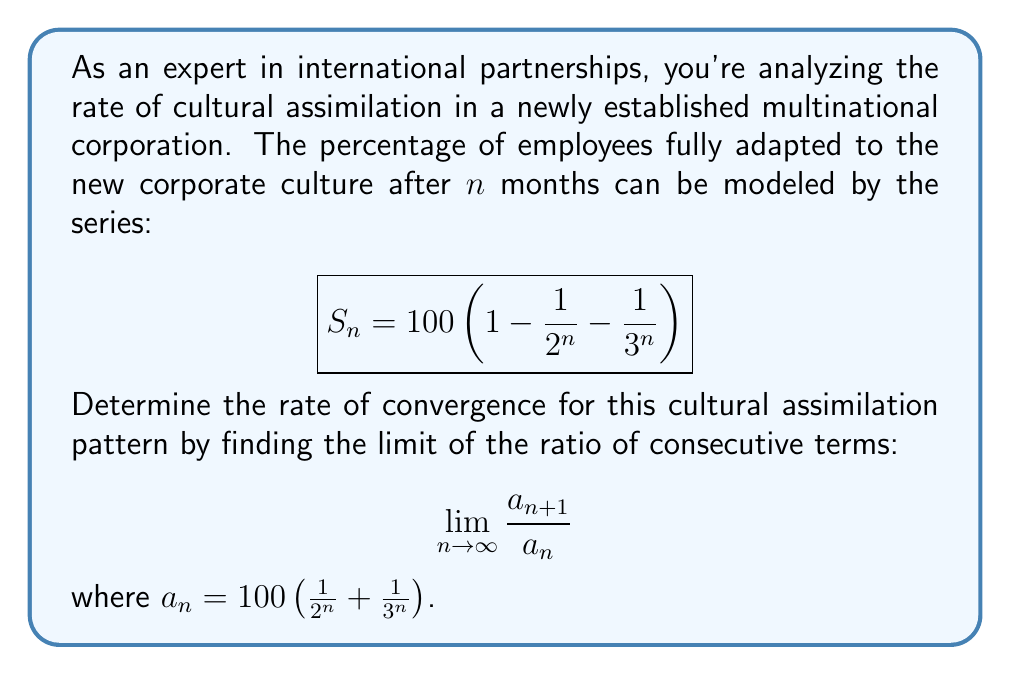Can you answer this question? To determine the rate of convergence, we need to find the limit of the ratio of consecutive terms. Let's break this down step-by-step:

1) First, let's define $a_n$:
   $$a_n = 100 \left(\frac{1}{2^n} + \frac{1}{3^n}\right)$$

2) Now, let's write out $a_{n+1}$:
   $$a_{n+1} = 100 \left(\frac{1}{2^{n+1}} + \frac{1}{3^{n+1}}\right)$$

3) We need to find the limit of their ratio as n approaches infinity:
   $$\lim_{n \to \infty} \frac{a_{n+1}}{a_n} = \lim_{n \to \infty} \frac{100 \left(\frac{1}{2^{n+1}} + \frac{1}{3^{n+1}}\right)}{100 \left(\frac{1}{2^n} + \frac{1}{3^n}\right)}$$

4) The 100 cancels out:
   $$\lim_{n \to \infty} \frac{\frac{1}{2^{n+1}} + \frac{1}{3^{n+1}}}{\frac{1}{2^n} + \frac{1}{3^n}}$$

5) We can simplify this:
   $$\lim_{n \to \infty} \frac{\frac{1}{2 \cdot 2^n} + \frac{1}{3 \cdot 3^n}}{\frac{1}{2^n} + \frac{1}{3^n}}$$

6) Multiply numerator and denominator by $2^n \cdot 3^n$:
   $$\lim_{n \to \infty} \frac{\frac{3^n}{2} + \frac{2^n}{3}}{3^n + 2^n}$$

7) As $n$ approaches infinity, $3^n$ grows much faster than $2^n$, so the $2^n$ terms become negligible:
   $$\lim_{n \to \infty} \frac{\frac{3^n}{2}}{3^n} = \frac{1}{2}$$

Therefore, the rate of convergence is $\frac{1}{2}$.
Answer: The rate of convergence for the cultural assimilation pattern is $\frac{1}{2}$. 